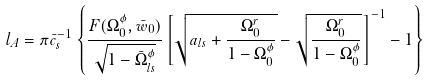Convert formula to latex. <formula><loc_0><loc_0><loc_500><loc_500>l _ { A } = \pi \bar { c } _ { s } ^ { - 1 } \left \{ \frac { F ( \Omega _ { 0 } ^ { \phi } , \bar { w } _ { 0 } ) } { \sqrt { 1 - \bar { \Omega } _ { l s } ^ { \phi } } } \left [ \sqrt { a _ { l s } + \frac { \Omega _ { 0 } ^ { r } } { 1 - \Omega _ { 0 } ^ { \phi } } } - \sqrt { \frac { \Omega _ { 0 } ^ { r } } { 1 - \Omega _ { 0 } ^ { \phi } } } \right ] ^ { - 1 } - 1 \right \}</formula> 